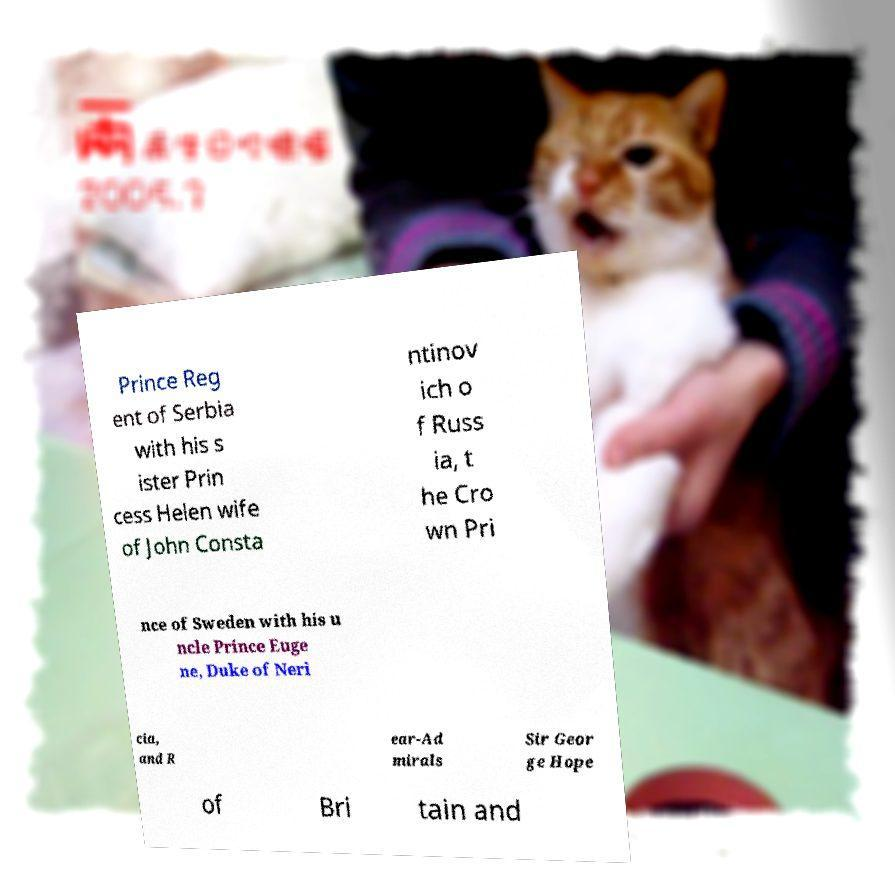Could you extract and type out the text from this image? Prince Reg ent of Serbia with his s ister Prin cess Helen wife of John Consta ntinov ich o f Russ ia, t he Cro wn Pri nce of Sweden with his u ncle Prince Euge ne, Duke of Neri cia, and R ear-Ad mirals Sir Geor ge Hope of Bri tain and 